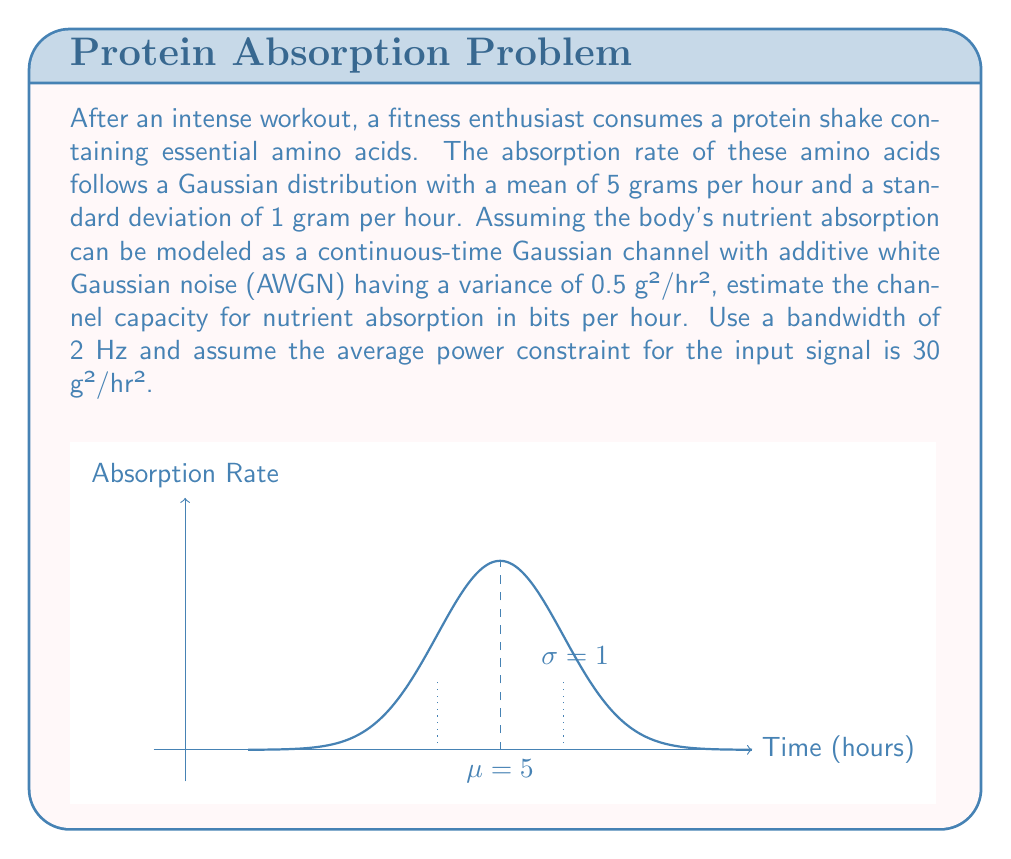Teach me how to tackle this problem. To solve this problem, we'll use the Shannon-Hartley theorem for channel capacity in a Gaussian channel. The steps are as follows:

1) The Shannon-Hartley theorem states that the channel capacity C is given by:

   $$C = B \log_2(1 + \frac{S}{N})$$

   where B is the bandwidth, S is the signal power, and N is the noise power.

2) We're given:
   - Bandwidth (B) = 2 Hz
   - Average power constraint (S) = 30 g²/hr²
   - Noise variance (N) = 0.5 g²/hr²

3) Substituting these values into the formula:

   $$C = 2 \log_2(1 + \frac{30}{0.5})$$

4) Simplify inside the logarithm:

   $$C = 2 \log_2(1 + 60)$$
   $$C = 2 log_2(61)$$

5) Calculate the logarithm:

   $$C = 2 * 5.93$$
   $$C = 11.86$$

6) Round to two decimal places:

   $$C \approx 11.86 \text{ bits/hour}$$

This means that the theoretical maximum rate at which information about nutrient absorption can be transmitted through this channel is approximately 11.86 bits per hour.
Answer: 11.86 bits/hour 